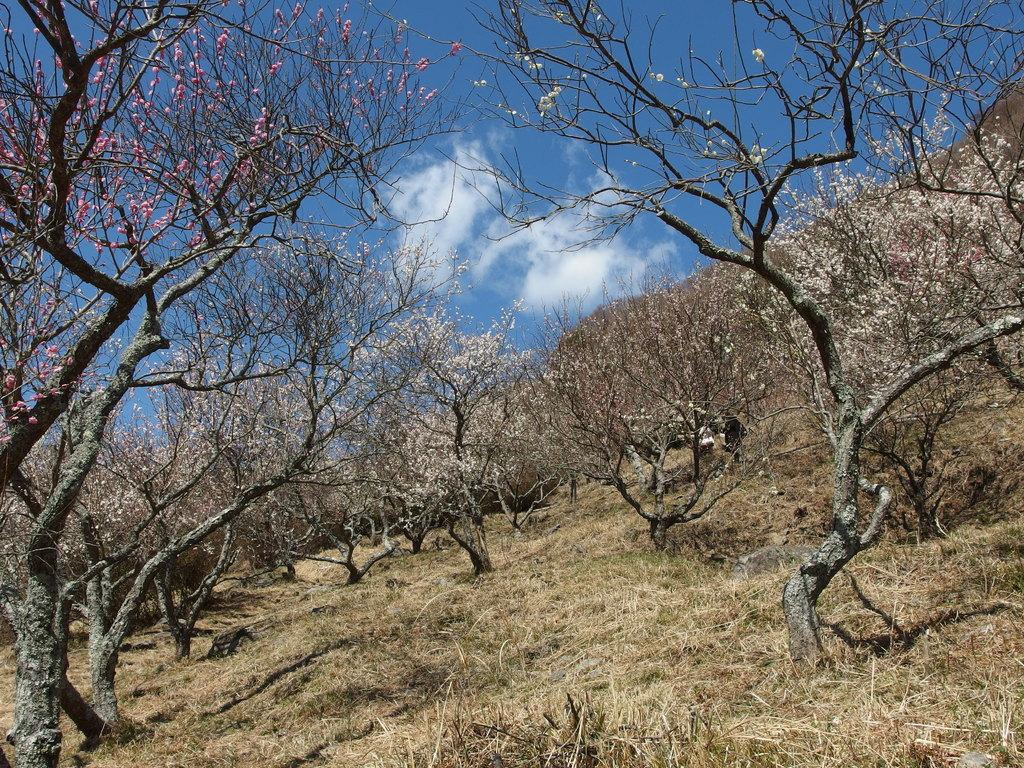What type of surface is visible in the image? There is ground visible in the image. What is growing on the ground in the image? There is grass on the ground in the image. What other plants can be seen in the image? There are trees in the image. What colors are the flowers on the trees? The flowers on the trees are pink and white in color. What can be seen in the background of the image? The sky is visible in the background of the image. What type of wall can be seen supporting the trees in the image? There is no wall present in the image; the trees are standing on their own. How many matches are visible in the image? There are no matches present in the image. 